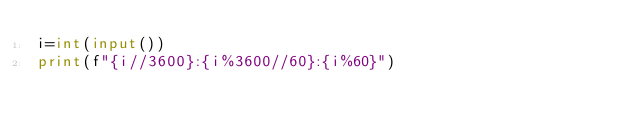Convert code to text. <code><loc_0><loc_0><loc_500><loc_500><_Python_>i=int(input())
print(f"{i//3600}:{i%3600//60}:{i%60}")
</code> 